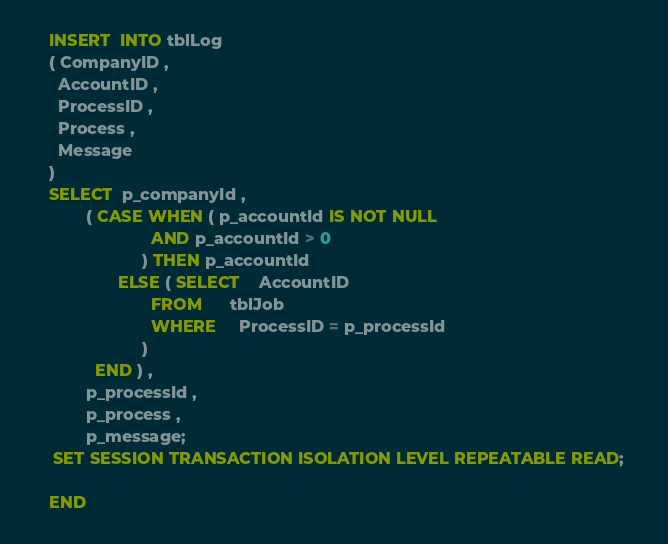Convert code to text. <code><loc_0><loc_0><loc_500><loc_500><_SQL_>	INSERT  INTO tblLog
    ( CompanyID ,
      AccountID ,
      ProcessID ,
      Process ,
      Message
    )
    SELECT  p_companyId ,
            ( CASE WHEN ( p_accountId IS NOT NULL
                          AND p_accountId > 0
                        ) THEN p_accountId
                   ELSE ( SELECT    AccountID
                          FROM      tblJob
                          WHERE     ProcessID = p_processId
                        )
              END ) ,
            p_processId ,
            p_process ,
            p_message;
     SET SESSION TRANSACTION ISOLATION LEVEL REPEATABLE READ;   
  
    END</code> 